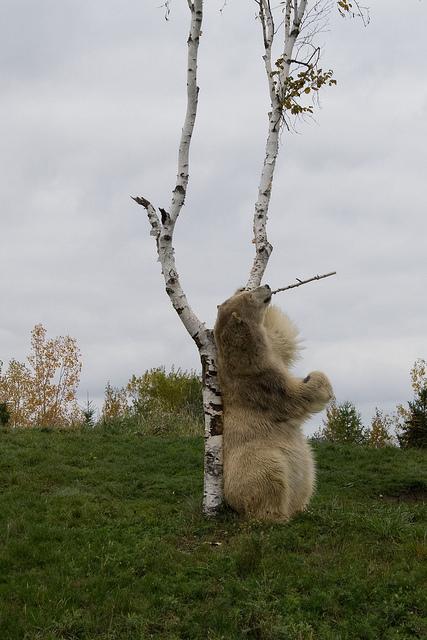What animal is this?
Write a very short answer. Bear. What kind of animal is this?
Give a very brief answer. Bear. What is the bear leaning against?
Short answer required. Tree. Is it cloudy?
Give a very brief answer. Yes. What type of bear is this?
Give a very brief answer. Polar. 